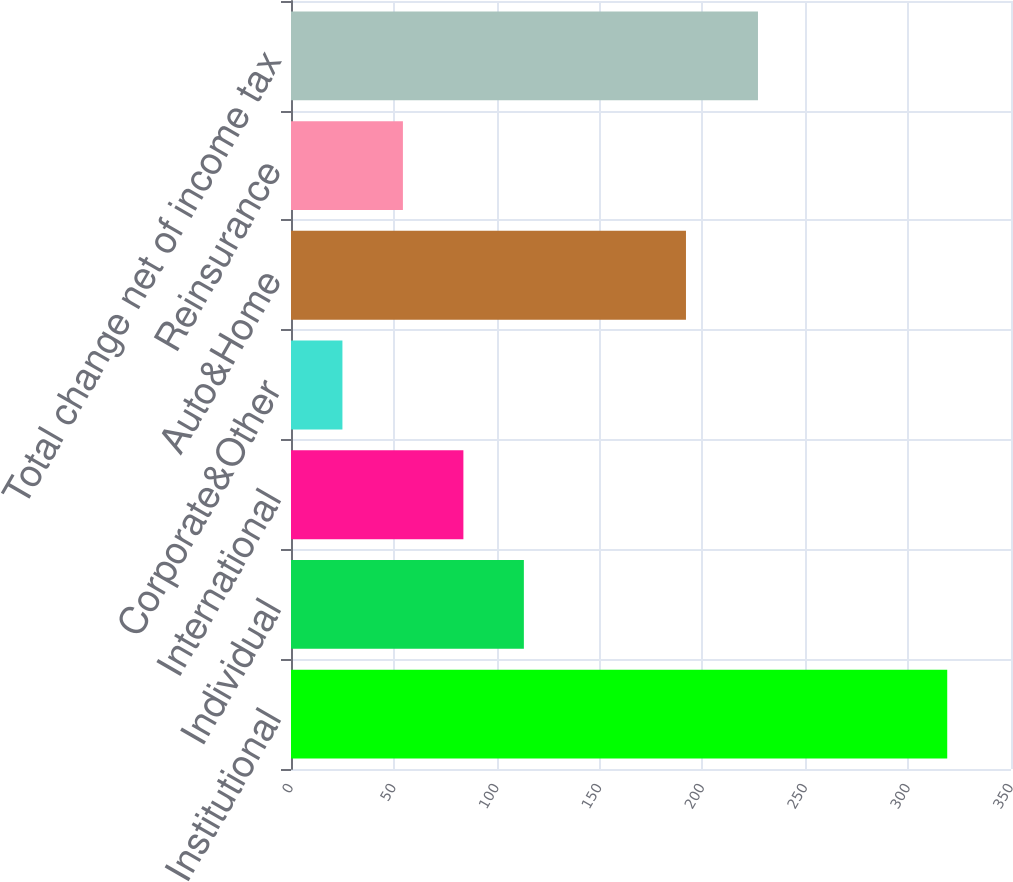Convert chart to OTSL. <chart><loc_0><loc_0><loc_500><loc_500><bar_chart><fcel>Institutional<fcel>Individual<fcel>International<fcel>Corporate&Other<fcel>Auto&Home<fcel>Reinsurance<fcel>Total change net of income tax<nl><fcel>319<fcel>113.2<fcel>83.8<fcel>25<fcel>192<fcel>54.4<fcel>227<nl></chart> 